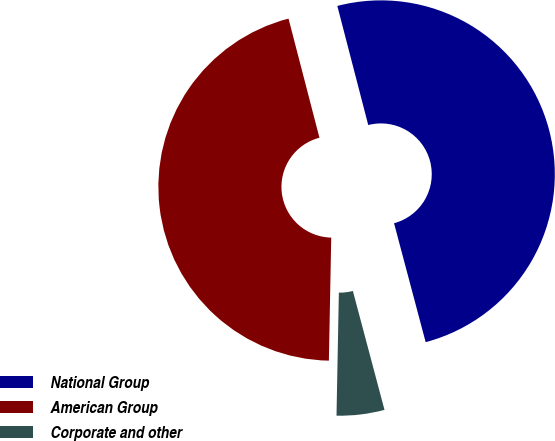Convert chart. <chart><loc_0><loc_0><loc_500><loc_500><pie_chart><fcel>National Group<fcel>American Group<fcel>Corporate and other<nl><fcel>49.9%<fcel>45.65%<fcel>4.44%<nl></chart> 